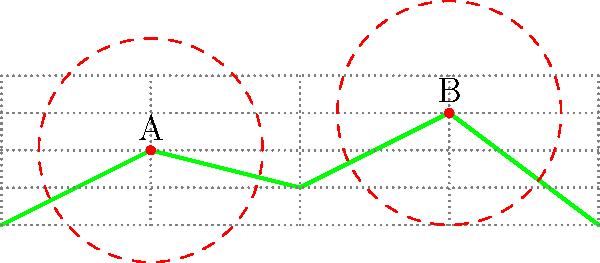In a military operation, you need to place communication towers to cover a specific terrain. The terrain profile is shown in the diagram, where each grid square represents 5km horizontally and 1km vertically. Two towers, A and B, have been placed as shown. Each tower has a coverage radius of 15km. What is the minimum number of additional towers needed to ensure complete coverage of the terrain from 0km to 80km? To solve this problem, we need to follow these steps:

1) First, let's analyze the current coverage:
   - Tower A is at (20km, 2km) and covers from 5km to 35km.
   - Tower B is at (60km, 3km) and covers from 45km to 75km.

2) The areas that need additional coverage are:
   - From 0km to 5km
   - From 35km to 45km
   - From 75km to 80km

3) To cover these areas efficiently:
   - We need one tower to cover 0km to 5km. Place it at (0km, 0km).
   - The gap between 35km and 45km can be covered by a tower at (40km, 1km).
   - The area from 75km to 80km can be covered by moving tower B slightly to the right, to (65km, 3km). This doesn't count as an additional tower.

4) Therefore, we need 2 additional towers to ensure complete coverage.

This solution minimizes the number of towers while ensuring no gaps in coverage along the entire 80km stretch of terrain.
Answer: 2 additional towers 